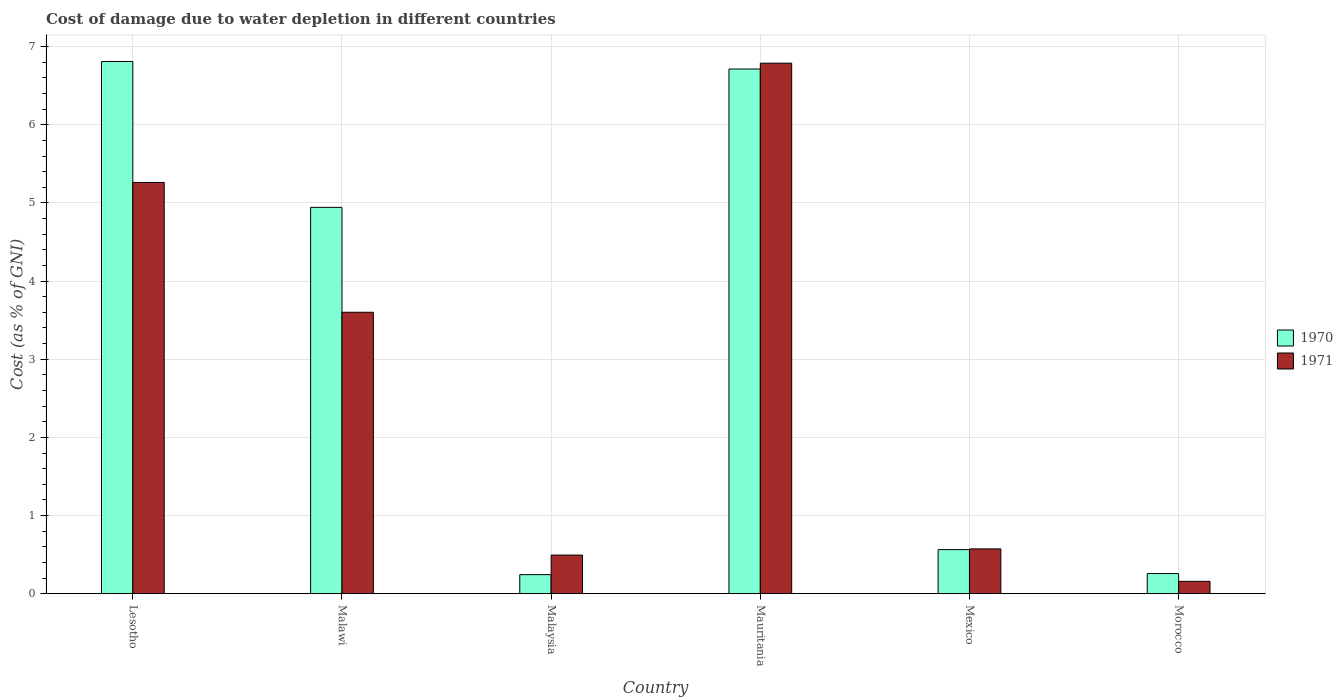How many bars are there on the 2nd tick from the left?
Offer a very short reply. 2. What is the label of the 4th group of bars from the left?
Your answer should be very brief. Mauritania. What is the cost of damage caused due to water depletion in 1970 in Mexico?
Provide a succinct answer. 0.56. Across all countries, what is the maximum cost of damage caused due to water depletion in 1971?
Give a very brief answer. 6.79. Across all countries, what is the minimum cost of damage caused due to water depletion in 1970?
Give a very brief answer. 0.24. In which country was the cost of damage caused due to water depletion in 1970 maximum?
Ensure brevity in your answer.  Lesotho. In which country was the cost of damage caused due to water depletion in 1971 minimum?
Your answer should be compact. Morocco. What is the total cost of damage caused due to water depletion in 1971 in the graph?
Your response must be concise. 16.88. What is the difference between the cost of damage caused due to water depletion in 1971 in Malawi and that in Malaysia?
Make the answer very short. 3.11. What is the difference between the cost of damage caused due to water depletion in 1970 in Morocco and the cost of damage caused due to water depletion in 1971 in Malawi?
Offer a very short reply. -3.34. What is the average cost of damage caused due to water depletion in 1971 per country?
Provide a succinct answer. 2.81. What is the difference between the cost of damage caused due to water depletion of/in 1970 and cost of damage caused due to water depletion of/in 1971 in Lesotho?
Offer a terse response. 1.55. In how many countries, is the cost of damage caused due to water depletion in 1970 greater than 0.8 %?
Make the answer very short. 3. What is the ratio of the cost of damage caused due to water depletion in 1970 in Lesotho to that in Malaysia?
Make the answer very short. 27.85. Is the difference between the cost of damage caused due to water depletion in 1970 in Mauritania and Morocco greater than the difference between the cost of damage caused due to water depletion in 1971 in Mauritania and Morocco?
Your answer should be compact. No. What is the difference between the highest and the second highest cost of damage caused due to water depletion in 1970?
Provide a succinct answer. -1.87. What is the difference between the highest and the lowest cost of damage caused due to water depletion in 1970?
Provide a short and direct response. 6.56. In how many countries, is the cost of damage caused due to water depletion in 1971 greater than the average cost of damage caused due to water depletion in 1971 taken over all countries?
Your response must be concise. 3. What does the 1st bar from the left in Mauritania represents?
Keep it short and to the point. 1970. What does the 1st bar from the right in Morocco represents?
Ensure brevity in your answer.  1971. How many bars are there?
Make the answer very short. 12. How many countries are there in the graph?
Offer a very short reply. 6. What is the difference between two consecutive major ticks on the Y-axis?
Your response must be concise. 1. Does the graph contain grids?
Ensure brevity in your answer.  Yes. Where does the legend appear in the graph?
Offer a terse response. Center right. How many legend labels are there?
Your answer should be compact. 2. How are the legend labels stacked?
Make the answer very short. Vertical. What is the title of the graph?
Offer a very short reply. Cost of damage due to water depletion in different countries. Does "2004" appear as one of the legend labels in the graph?
Provide a short and direct response. No. What is the label or title of the Y-axis?
Make the answer very short. Cost (as % of GNI). What is the Cost (as % of GNI) of 1970 in Lesotho?
Your answer should be compact. 6.81. What is the Cost (as % of GNI) in 1971 in Lesotho?
Give a very brief answer. 5.26. What is the Cost (as % of GNI) in 1970 in Malawi?
Keep it short and to the point. 4.94. What is the Cost (as % of GNI) of 1971 in Malawi?
Offer a terse response. 3.6. What is the Cost (as % of GNI) in 1970 in Malaysia?
Your answer should be very brief. 0.24. What is the Cost (as % of GNI) in 1971 in Malaysia?
Make the answer very short. 0.49. What is the Cost (as % of GNI) of 1970 in Mauritania?
Keep it short and to the point. 6.71. What is the Cost (as % of GNI) in 1971 in Mauritania?
Provide a succinct answer. 6.79. What is the Cost (as % of GNI) in 1970 in Mexico?
Make the answer very short. 0.56. What is the Cost (as % of GNI) in 1971 in Mexico?
Provide a succinct answer. 0.57. What is the Cost (as % of GNI) of 1970 in Morocco?
Keep it short and to the point. 0.26. What is the Cost (as % of GNI) in 1971 in Morocco?
Offer a terse response. 0.16. Across all countries, what is the maximum Cost (as % of GNI) in 1970?
Keep it short and to the point. 6.81. Across all countries, what is the maximum Cost (as % of GNI) of 1971?
Your response must be concise. 6.79. Across all countries, what is the minimum Cost (as % of GNI) in 1970?
Offer a very short reply. 0.24. Across all countries, what is the minimum Cost (as % of GNI) in 1971?
Your response must be concise. 0.16. What is the total Cost (as % of GNI) of 1970 in the graph?
Your response must be concise. 19.53. What is the total Cost (as % of GNI) of 1971 in the graph?
Your response must be concise. 16.88. What is the difference between the Cost (as % of GNI) of 1970 in Lesotho and that in Malawi?
Your answer should be compact. 1.87. What is the difference between the Cost (as % of GNI) in 1971 in Lesotho and that in Malawi?
Provide a succinct answer. 1.66. What is the difference between the Cost (as % of GNI) in 1970 in Lesotho and that in Malaysia?
Give a very brief answer. 6.56. What is the difference between the Cost (as % of GNI) in 1971 in Lesotho and that in Malaysia?
Your response must be concise. 4.77. What is the difference between the Cost (as % of GNI) in 1970 in Lesotho and that in Mauritania?
Your answer should be very brief. 0.1. What is the difference between the Cost (as % of GNI) of 1971 in Lesotho and that in Mauritania?
Offer a very short reply. -1.53. What is the difference between the Cost (as % of GNI) in 1970 in Lesotho and that in Mexico?
Your response must be concise. 6.24. What is the difference between the Cost (as % of GNI) of 1971 in Lesotho and that in Mexico?
Your response must be concise. 4.69. What is the difference between the Cost (as % of GNI) of 1970 in Lesotho and that in Morocco?
Give a very brief answer. 6.55. What is the difference between the Cost (as % of GNI) of 1971 in Lesotho and that in Morocco?
Make the answer very short. 5.1. What is the difference between the Cost (as % of GNI) in 1970 in Malawi and that in Malaysia?
Provide a short and direct response. 4.7. What is the difference between the Cost (as % of GNI) in 1971 in Malawi and that in Malaysia?
Ensure brevity in your answer.  3.11. What is the difference between the Cost (as % of GNI) of 1970 in Malawi and that in Mauritania?
Your answer should be compact. -1.77. What is the difference between the Cost (as % of GNI) of 1971 in Malawi and that in Mauritania?
Provide a succinct answer. -3.19. What is the difference between the Cost (as % of GNI) of 1970 in Malawi and that in Mexico?
Make the answer very short. 4.38. What is the difference between the Cost (as % of GNI) of 1971 in Malawi and that in Mexico?
Keep it short and to the point. 3.03. What is the difference between the Cost (as % of GNI) in 1970 in Malawi and that in Morocco?
Provide a short and direct response. 4.68. What is the difference between the Cost (as % of GNI) in 1971 in Malawi and that in Morocco?
Ensure brevity in your answer.  3.44. What is the difference between the Cost (as % of GNI) of 1970 in Malaysia and that in Mauritania?
Keep it short and to the point. -6.47. What is the difference between the Cost (as % of GNI) of 1971 in Malaysia and that in Mauritania?
Make the answer very short. -6.29. What is the difference between the Cost (as % of GNI) in 1970 in Malaysia and that in Mexico?
Ensure brevity in your answer.  -0.32. What is the difference between the Cost (as % of GNI) in 1971 in Malaysia and that in Mexico?
Provide a succinct answer. -0.08. What is the difference between the Cost (as % of GNI) of 1970 in Malaysia and that in Morocco?
Offer a terse response. -0.01. What is the difference between the Cost (as % of GNI) of 1971 in Malaysia and that in Morocco?
Provide a short and direct response. 0.34. What is the difference between the Cost (as % of GNI) of 1970 in Mauritania and that in Mexico?
Your answer should be very brief. 6.15. What is the difference between the Cost (as % of GNI) of 1971 in Mauritania and that in Mexico?
Your response must be concise. 6.21. What is the difference between the Cost (as % of GNI) in 1970 in Mauritania and that in Morocco?
Keep it short and to the point. 6.45. What is the difference between the Cost (as % of GNI) in 1971 in Mauritania and that in Morocco?
Your answer should be compact. 6.63. What is the difference between the Cost (as % of GNI) of 1970 in Mexico and that in Morocco?
Ensure brevity in your answer.  0.31. What is the difference between the Cost (as % of GNI) in 1971 in Mexico and that in Morocco?
Give a very brief answer. 0.41. What is the difference between the Cost (as % of GNI) in 1970 in Lesotho and the Cost (as % of GNI) in 1971 in Malawi?
Provide a succinct answer. 3.21. What is the difference between the Cost (as % of GNI) of 1970 in Lesotho and the Cost (as % of GNI) of 1971 in Malaysia?
Make the answer very short. 6.31. What is the difference between the Cost (as % of GNI) of 1970 in Lesotho and the Cost (as % of GNI) of 1971 in Mauritania?
Your answer should be very brief. 0.02. What is the difference between the Cost (as % of GNI) in 1970 in Lesotho and the Cost (as % of GNI) in 1971 in Mexico?
Keep it short and to the point. 6.24. What is the difference between the Cost (as % of GNI) of 1970 in Lesotho and the Cost (as % of GNI) of 1971 in Morocco?
Your response must be concise. 6.65. What is the difference between the Cost (as % of GNI) in 1970 in Malawi and the Cost (as % of GNI) in 1971 in Malaysia?
Keep it short and to the point. 4.45. What is the difference between the Cost (as % of GNI) in 1970 in Malawi and the Cost (as % of GNI) in 1971 in Mauritania?
Provide a succinct answer. -1.84. What is the difference between the Cost (as % of GNI) in 1970 in Malawi and the Cost (as % of GNI) in 1971 in Mexico?
Your answer should be very brief. 4.37. What is the difference between the Cost (as % of GNI) of 1970 in Malawi and the Cost (as % of GNI) of 1971 in Morocco?
Your answer should be compact. 4.78. What is the difference between the Cost (as % of GNI) in 1970 in Malaysia and the Cost (as % of GNI) in 1971 in Mauritania?
Provide a short and direct response. -6.54. What is the difference between the Cost (as % of GNI) of 1970 in Malaysia and the Cost (as % of GNI) of 1971 in Mexico?
Offer a terse response. -0.33. What is the difference between the Cost (as % of GNI) in 1970 in Malaysia and the Cost (as % of GNI) in 1971 in Morocco?
Offer a terse response. 0.09. What is the difference between the Cost (as % of GNI) of 1970 in Mauritania and the Cost (as % of GNI) of 1971 in Mexico?
Provide a short and direct response. 6.14. What is the difference between the Cost (as % of GNI) of 1970 in Mauritania and the Cost (as % of GNI) of 1971 in Morocco?
Provide a short and direct response. 6.55. What is the difference between the Cost (as % of GNI) in 1970 in Mexico and the Cost (as % of GNI) in 1971 in Morocco?
Offer a very short reply. 0.41. What is the average Cost (as % of GNI) in 1970 per country?
Give a very brief answer. 3.26. What is the average Cost (as % of GNI) of 1971 per country?
Keep it short and to the point. 2.81. What is the difference between the Cost (as % of GNI) in 1970 and Cost (as % of GNI) in 1971 in Lesotho?
Keep it short and to the point. 1.55. What is the difference between the Cost (as % of GNI) in 1970 and Cost (as % of GNI) in 1971 in Malawi?
Your answer should be very brief. 1.34. What is the difference between the Cost (as % of GNI) of 1970 and Cost (as % of GNI) of 1971 in Malaysia?
Offer a terse response. -0.25. What is the difference between the Cost (as % of GNI) of 1970 and Cost (as % of GNI) of 1971 in Mauritania?
Offer a terse response. -0.07. What is the difference between the Cost (as % of GNI) in 1970 and Cost (as % of GNI) in 1971 in Mexico?
Keep it short and to the point. -0.01. What is the difference between the Cost (as % of GNI) of 1970 and Cost (as % of GNI) of 1971 in Morocco?
Make the answer very short. 0.1. What is the ratio of the Cost (as % of GNI) of 1970 in Lesotho to that in Malawi?
Offer a terse response. 1.38. What is the ratio of the Cost (as % of GNI) in 1971 in Lesotho to that in Malawi?
Offer a terse response. 1.46. What is the ratio of the Cost (as % of GNI) in 1970 in Lesotho to that in Malaysia?
Provide a succinct answer. 27.85. What is the ratio of the Cost (as % of GNI) of 1971 in Lesotho to that in Malaysia?
Provide a short and direct response. 10.63. What is the ratio of the Cost (as % of GNI) in 1970 in Lesotho to that in Mauritania?
Offer a terse response. 1.01. What is the ratio of the Cost (as % of GNI) in 1971 in Lesotho to that in Mauritania?
Give a very brief answer. 0.78. What is the ratio of the Cost (as % of GNI) of 1970 in Lesotho to that in Mexico?
Your answer should be compact. 12.06. What is the ratio of the Cost (as % of GNI) in 1971 in Lesotho to that in Mexico?
Ensure brevity in your answer.  9.17. What is the ratio of the Cost (as % of GNI) in 1970 in Lesotho to that in Morocco?
Offer a very short reply. 26.38. What is the ratio of the Cost (as % of GNI) in 1971 in Lesotho to that in Morocco?
Keep it short and to the point. 33.13. What is the ratio of the Cost (as % of GNI) of 1970 in Malawi to that in Malaysia?
Provide a short and direct response. 20.22. What is the ratio of the Cost (as % of GNI) in 1971 in Malawi to that in Malaysia?
Your response must be concise. 7.28. What is the ratio of the Cost (as % of GNI) in 1970 in Malawi to that in Mauritania?
Ensure brevity in your answer.  0.74. What is the ratio of the Cost (as % of GNI) in 1971 in Malawi to that in Mauritania?
Make the answer very short. 0.53. What is the ratio of the Cost (as % of GNI) in 1970 in Malawi to that in Mexico?
Your response must be concise. 8.75. What is the ratio of the Cost (as % of GNI) in 1971 in Malawi to that in Mexico?
Provide a short and direct response. 6.27. What is the ratio of the Cost (as % of GNI) of 1970 in Malawi to that in Morocco?
Provide a short and direct response. 19.15. What is the ratio of the Cost (as % of GNI) of 1971 in Malawi to that in Morocco?
Your response must be concise. 22.67. What is the ratio of the Cost (as % of GNI) of 1970 in Malaysia to that in Mauritania?
Provide a short and direct response. 0.04. What is the ratio of the Cost (as % of GNI) in 1971 in Malaysia to that in Mauritania?
Keep it short and to the point. 0.07. What is the ratio of the Cost (as % of GNI) in 1970 in Malaysia to that in Mexico?
Your answer should be very brief. 0.43. What is the ratio of the Cost (as % of GNI) of 1971 in Malaysia to that in Mexico?
Provide a succinct answer. 0.86. What is the ratio of the Cost (as % of GNI) in 1970 in Malaysia to that in Morocco?
Offer a very short reply. 0.95. What is the ratio of the Cost (as % of GNI) in 1971 in Malaysia to that in Morocco?
Your answer should be very brief. 3.12. What is the ratio of the Cost (as % of GNI) of 1970 in Mauritania to that in Mexico?
Provide a succinct answer. 11.89. What is the ratio of the Cost (as % of GNI) of 1971 in Mauritania to that in Mexico?
Provide a succinct answer. 11.83. What is the ratio of the Cost (as % of GNI) in 1970 in Mauritania to that in Morocco?
Provide a succinct answer. 26. What is the ratio of the Cost (as % of GNI) of 1971 in Mauritania to that in Morocco?
Your response must be concise. 42.73. What is the ratio of the Cost (as % of GNI) of 1970 in Mexico to that in Morocco?
Offer a very short reply. 2.19. What is the ratio of the Cost (as % of GNI) in 1971 in Mexico to that in Morocco?
Ensure brevity in your answer.  3.61. What is the difference between the highest and the second highest Cost (as % of GNI) in 1970?
Offer a terse response. 0.1. What is the difference between the highest and the second highest Cost (as % of GNI) in 1971?
Offer a terse response. 1.53. What is the difference between the highest and the lowest Cost (as % of GNI) in 1970?
Provide a succinct answer. 6.56. What is the difference between the highest and the lowest Cost (as % of GNI) in 1971?
Provide a short and direct response. 6.63. 